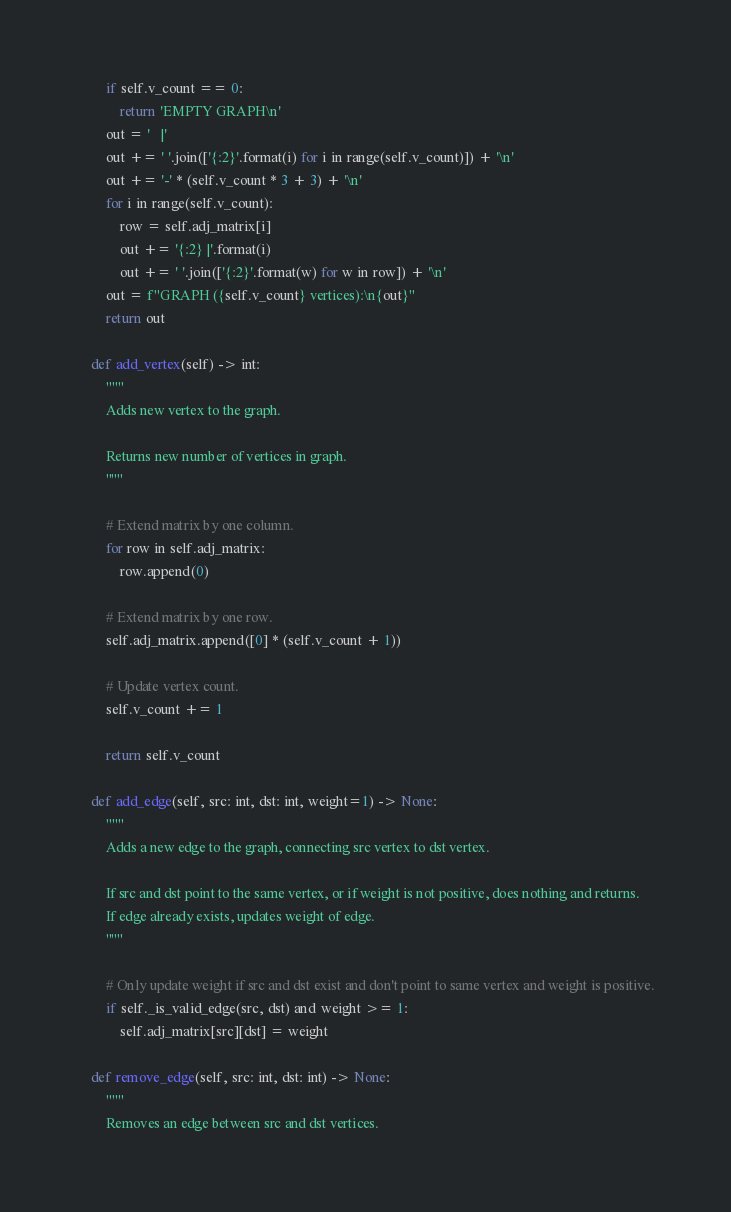<code> <loc_0><loc_0><loc_500><loc_500><_Python_>        if self.v_count == 0:
            return 'EMPTY GRAPH\n'
        out = '   |'
        out += ' '.join(['{:2}'.format(i) for i in range(self.v_count)]) + '\n'
        out += '-' * (self.v_count * 3 + 3) + '\n'
        for i in range(self.v_count):
            row = self.adj_matrix[i]
            out += '{:2} |'.format(i)
            out += ' '.join(['{:2}'.format(w) for w in row]) + '\n'
        out = f"GRAPH ({self.v_count} vertices):\n{out}"
        return out

    def add_vertex(self) -> int:
        """
        Adds new vertex to the graph.

        Returns new number of vertices in graph.
        """

        # Extend matrix by one column.
        for row in self.adj_matrix:
            row.append(0)

        # Extend matrix by one row.
        self.adj_matrix.append([0] * (self.v_count + 1))

        # Update vertex count.
        self.v_count += 1

        return self.v_count

    def add_edge(self, src: int, dst: int, weight=1) -> None:
        """
        Adds a new edge to the graph, connecting src vertex to dst vertex.

        If src and dst point to the same vertex, or if weight is not positive, does nothing and returns.
        If edge already exists, updates weight of edge.
        """

        # Only update weight if src and dst exist and don't point to same vertex and weight is positive.
        if self._is_valid_edge(src, dst) and weight >= 1:
            self.adj_matrix[src][dst] = weight

    def remove_edge(self, src: int, dst: int) -> None:
        """
        Removes an edge between src and dst vertices.
</code> 